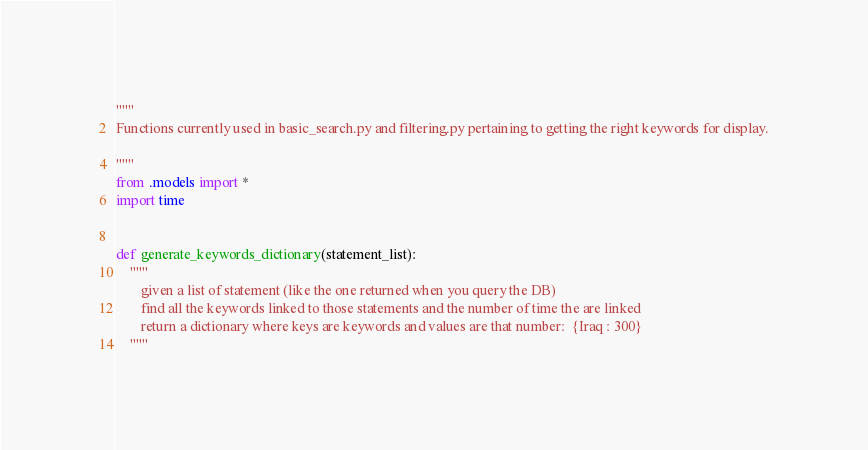Convert code to text. <code><loc_0><loc_0><loc_500><loc_500><_Python_>"""
Functions currently used in basic_search.py and filtering.py pertaining to getting the right keywords for display.

"""
from .models import *
import time


def generate_keywords_dictionary(statement_list):
    """
       given a list of statement (like the one returned when you query the DB)
       find all the keywords linked to those statements and the number of time the are linked
       return a dictionary where keys are keywords and values are that number:  {Iraq : 300}
    """
</code> 